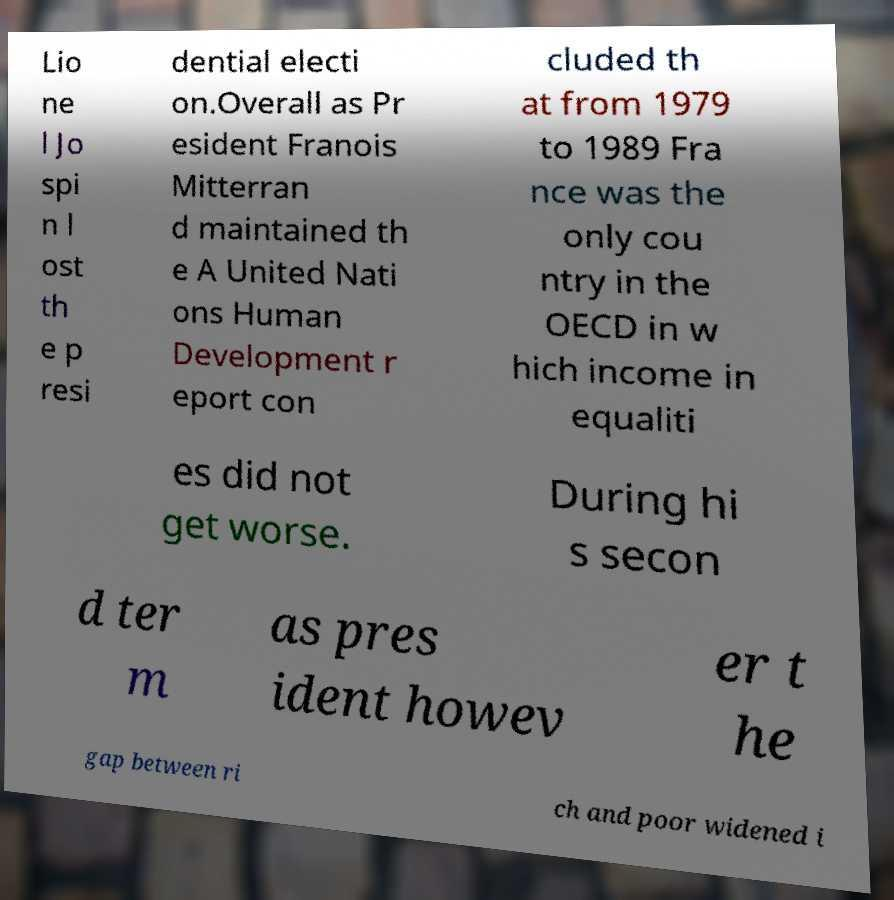What messages or text are displayed in this image? I need them in a readable, typed format. Lio ne l Jo spi n l ost th e p resi dential electi on.Overall as Pr esident Franois Mitterran d maintained th e A United Nati ons Human Development r eport con cluded th at from 1979 to 1989 Fra nce was the only cou ntry in the OECD in w hich income in equaliti es did not get worse. During hi s secon d ter m as pres ident howev er t he gap between ri ch and poor widened i 